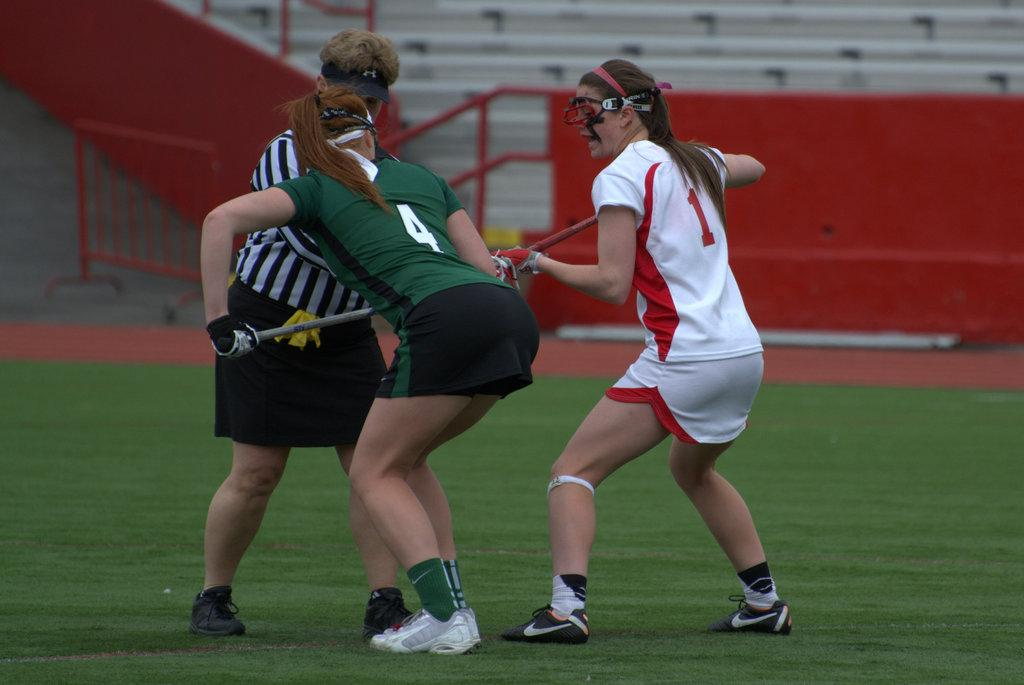Who is present in the image? There are people in the image. What are the people doing in the image? The people are playing a game. Where is the game being played? The game is being played on the ground. What can be seen in the background of the image? There are metal rods visible in the background of the image. What sound do the pigs make while playing the game in the image? There are no pigs present in the image, so it is not possible to determine the sound they might make. 